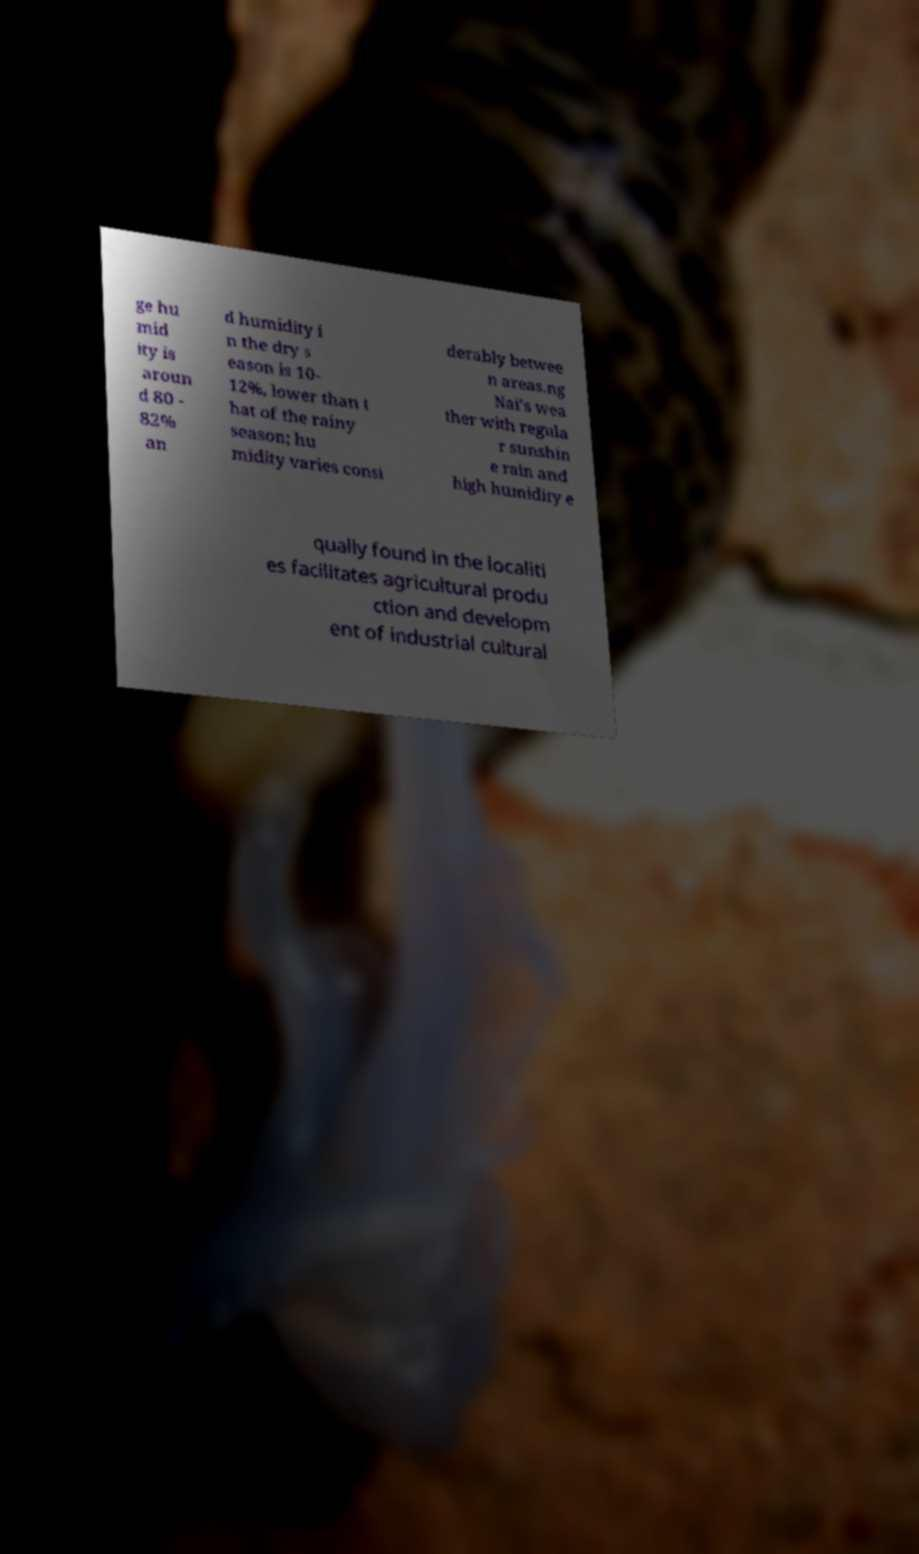Please read and relay the text visible in this image. What does it say? ge hu mid ity is aroun d 80 - 82% an d humidity i n the dry s eason is 10- 12%, lower than t hat of the rainy season; hu midity varies consi derably betwee n areas.ng Nai's wea ther with regula r sunshin e rain and high humidity e qually found in the localiti es facilitates agricultural produ ction and developm ent of industrial cultural 